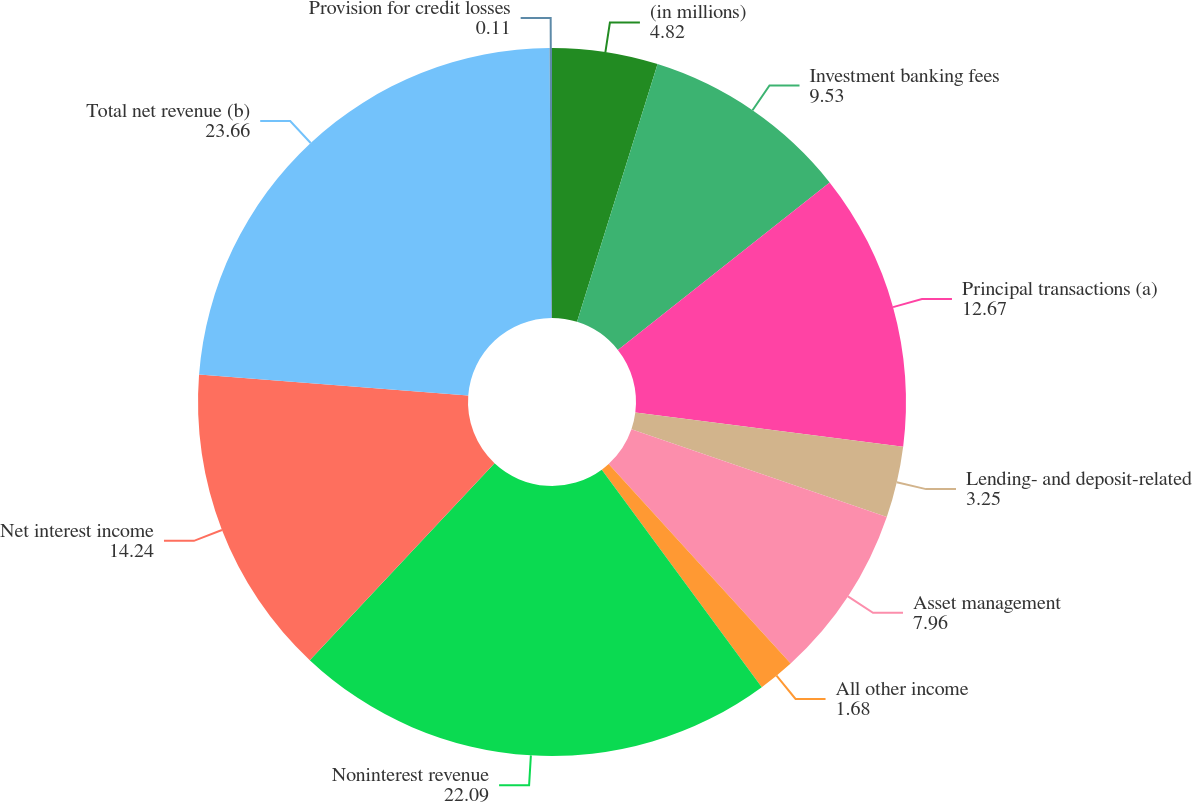<chart> <loc_0><loc_0><loc_500><loc_500><pie_chart><fcel>(in millions)<fcel>Investment banking fees<fcel>Principal transactions (a)<fcel>Lending- and deposit-related<fcel>Asset management<fcel>All other income<fcel>Noninterest revenue<fcel>Net interest income<fcel>Total net revenue (b)<fcel>Provision for credit losses<nl><fcel>4.82%<fcel>9.53%<fcel>12.67%<fcel>3.25%<fcel>7.96%<fcel>1.68%<fcel>22.09%<fcel>14.24%<fcel>23.66%<fcel>0.11%<nl></chart> 